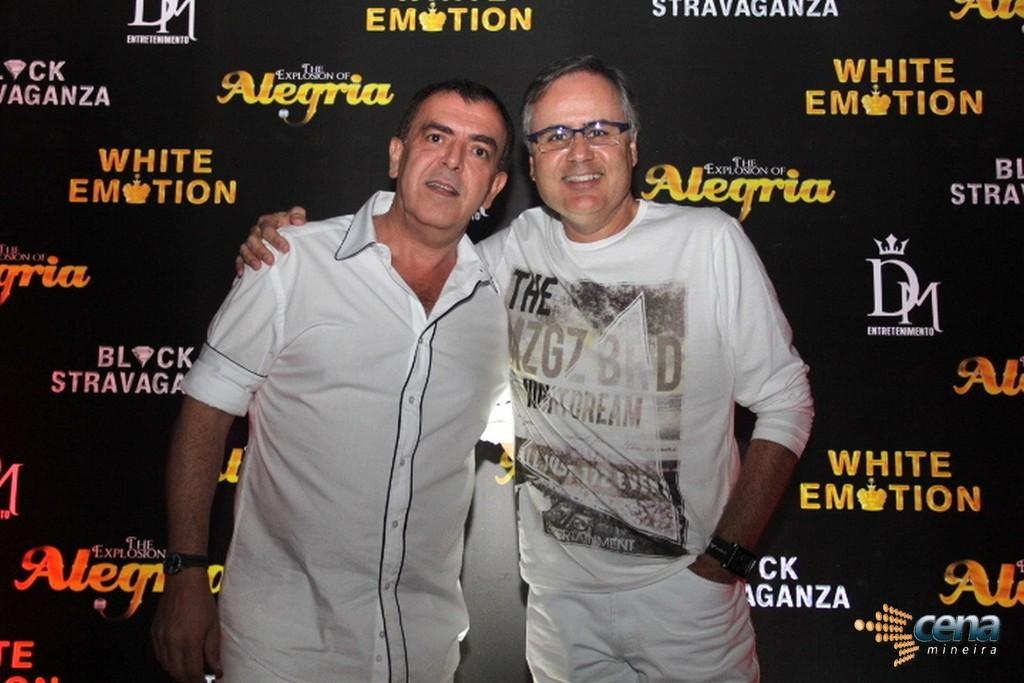<image>
Write a terse but informative summary of the picture. Two middle aged me pose in front of a background that says "White Emotion." 